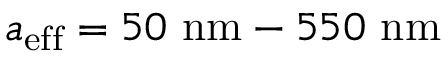<formula> <loc_0><loc_0><loc_500><loc_500>{ a _ { e f f } = 5 0 \ n m - 5 5 0 \ n m }</formula> 